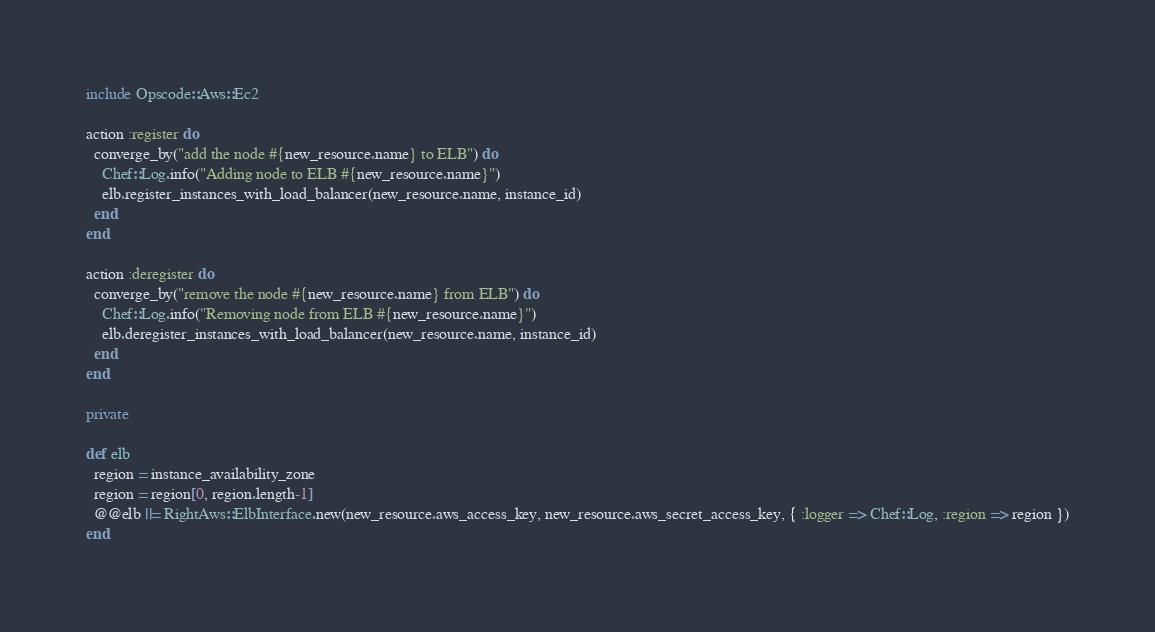Convert code to text. <code><loc_0><loc_0><loc_500><loc_500><_Ruby_>include Opscode::Aws::Ec2

action :register do
  converge_by("add the node #{new_resource.name} to ELB") do
    Chef::Log.info("Adding node to ELB #{new_resource.name}")
    elb.register_instances_with_load_balancer(new_resource.name, instance_id)
  end
end

action :deregister do
  converge_by("remove the node #{new_resource.name} from ELB") do
    Chef::Log.info("Removing node from ELB #{new_resource.name}")
    elb.deregister_instances_with_load_balancer(new_resource.name, instance_id)
  end
end

private

def elb
  region = instance_availability_zone
  region = region[0, region.length-1]
  @@elb ||= RightAws::ElbInterface.new(new_resource.aws_access_key, new_resource.aws_secret_access_key, { :logger => Chef::Log, :region => region })
end

</code> 